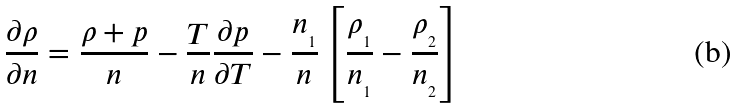Convert formula to latex. <formula><loc_0><loc_0><loc_500><loc_500>\frac { \partial \rho } { \partial n } = \frac { \rho + p } { n } - \frac { T } { n } \frac { \partial p } { \partial T } - \frac { n _ { _ { 1 } } } { n } \left [ \frac { \rho _ { _ { 1 } } } { n _ { _ { 1 } } } - \frac { \rho _ { _ { 2 } } } { n _ { _ { 2 } } } \right ]</formula> 